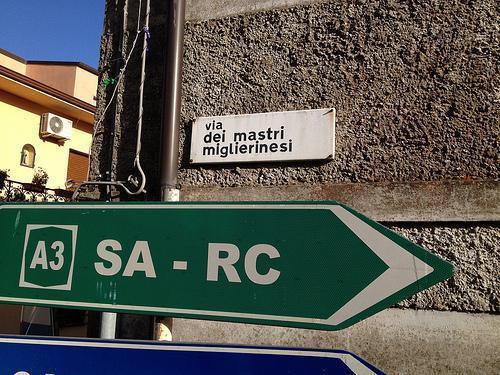How many signs are in the picture?
Give a very brief answer. 3. How many letters are on the green sign?
Give a very brief answer. 5. How many words are on the white sign?
Give a very brief answer. 4. How many air conditioning units are attached to the yellow building?
Give a very brief answer. 1. 